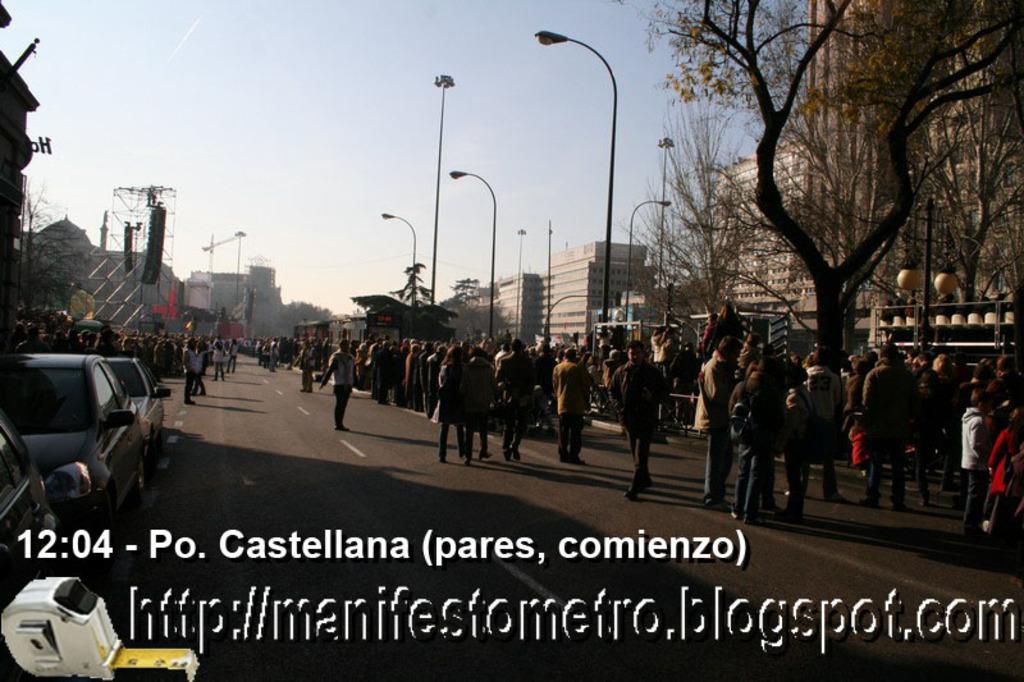How would you summarize this image in a sentence or two? In the picture I can see a group of people are standing on the road. In the background I can see vehicles, buildings, street lights, the sky, trees and some other objects. I can also see something written on the image. 